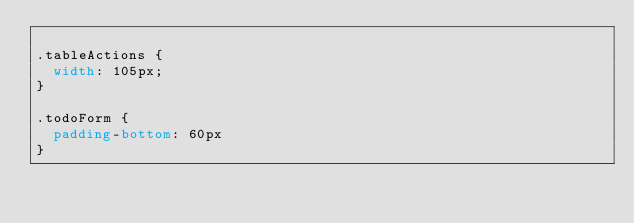<code> <loc_0><loc_0><loc_500><loc_500><_CSS_>
.tableActions {
  width: 105px;
}

.todoForm {
  padding-bottom: 60px
}</code> 